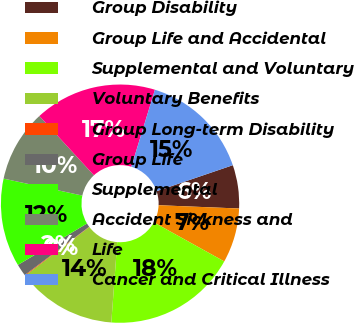Convert chart to OTSL. <chart><loc_0><loc_0><loc_500><loc_500><pie_chart><fcel>Group Disability<fcel>Group Life and Accidental<fcel>Supplemental and Voluntary<fcel>Voluntary Benefits<fcel>Group Long-term Disability<fcel>Group Life<fcel>Supplemental<fcel>Accident Sickness and<fcel>Life<fcel>Cancer and Critical Illness<nl><fcel>5.88%<fcel>7.41%<fcel>18.11%<fcel>13.5%<fcel>0.1%<fcel>1.63%<fcel>11.97%<fcel>9.79%<fcel>16.57%<fcel>15.04%<nl></chart> 